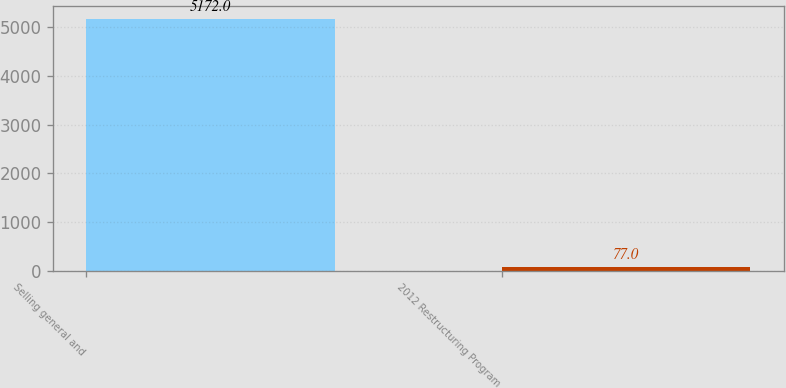Convert chart. <chart><loc_0><loc_0><loc_500><loc_500><bar_chart><fcel>Selling general and<fcel>2012 Restructuring Program<nl><fcel>5172<fcel>77<nl></chart> 